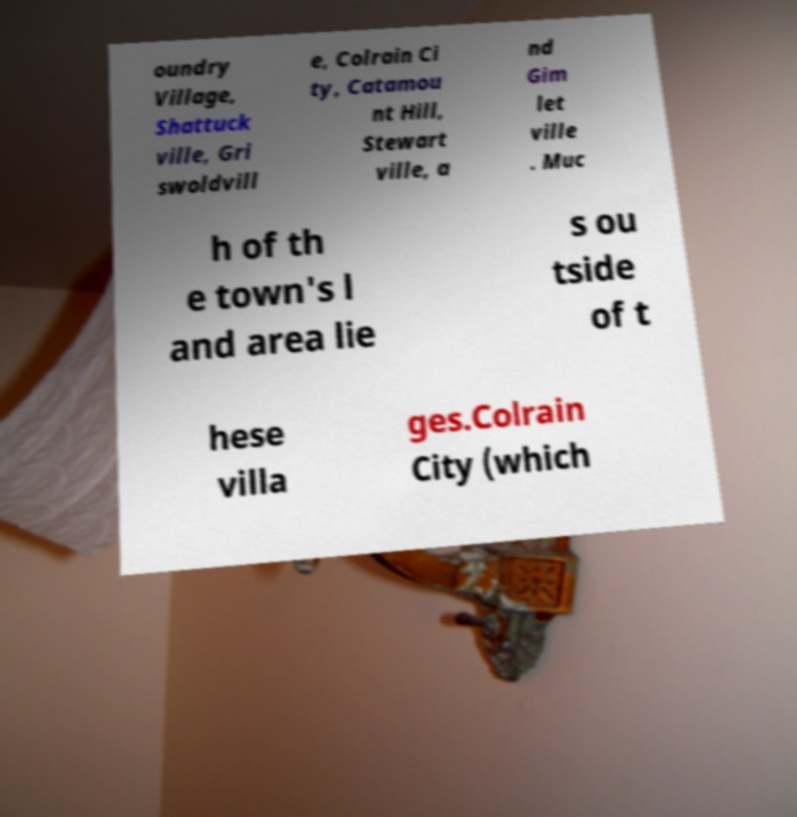There's text embedded in this image that I need extracted. Can you transcribe it verbatim? oundry Village, Shattuck ville, Gri swoldvill e, Colrain Ci ty, Catamou nt Hill, Stewart ville, a nd Gim let ville . Muc h of th e town's l and area lie s ou tside of t hese villa ges.Colrain City (which 